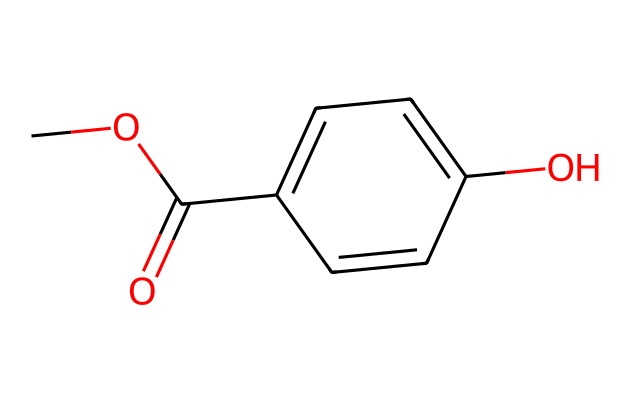What is the molecular formula of methylparaben? To find the molecular formula, count the number of each type of atom in the chemical structure. The structure has 9 carbon atoms (C), 10 hydrogen atoms (H), and 3 oxygen atoms (O). Thus, the molecular formula is C8H8O3.
Answer: C8H8O3 How many hydroxyl groups are present in methylparaben? A hydroxyl group is represented by -OH in the structure. The structure has one -OH group attached to a carbon ring, indicating the presence of one hydroxyl group.
Answer: 1 What type of functional group does methylparaben contain? The esters and hydroxyls can be identified in the structure. Methylparaben contains an ester functional group due to the presence of the -COO- linkage, and it also includes a hydroxyl group.
Answer: ester What is the significance of the para position in methylparaben? The para position refers to the relative placement of substituents on the aromatic ring. In methylparaben, the -OCH3 and the -OH groups are located at para positions on the benzene ring, which helps stabilize the molecule’s structure and enhances preservative activity.
Answer: stabilizes How does the presence of the methyl group affect the properties of methylparaben? The methyl group (-OCH3) increases lipophilicity, enabling better penetration through skin barriers, which is important for its effectiveness in topical formulations. This also affects solubility in nonpolar environments.
Answer: enhances penetration What is the primary purpose of methylparaben in topical pain relief creams? Methylparaben serves as a preservative to prevent microbial growth in formulations, thereby extending shelf life and maintaining product integrity.
Answer: preservative 